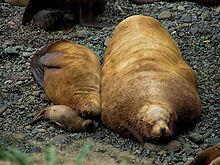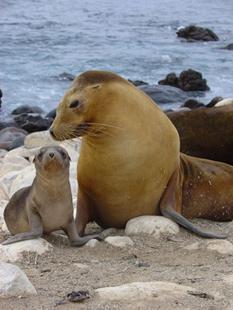The first image is the image on the left, the second image is the image on the right. Given the left and right images, does the statement "An image shows an adult seal on the right with its neck turned to point its nose down toward a baby seal." hold true? Answer yes or no. Yes. The first image is the image on the left, the second image is the image on the right. For the images displayed, is the sentence "The right image contains an adult seal with a child seal." factually correct? Answer yes or no. Yes. 